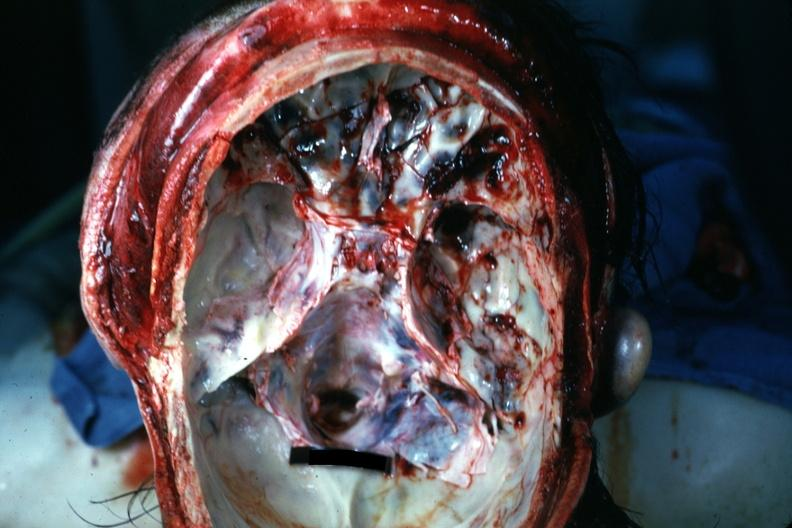what is present?
Answer the question using a single word or phrase. Bone 